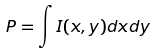Convert formula to latex. <formula><loc_0><loc_0><loc_500><loc_500>P = \int I ( x , y ) d x d y</formula> 